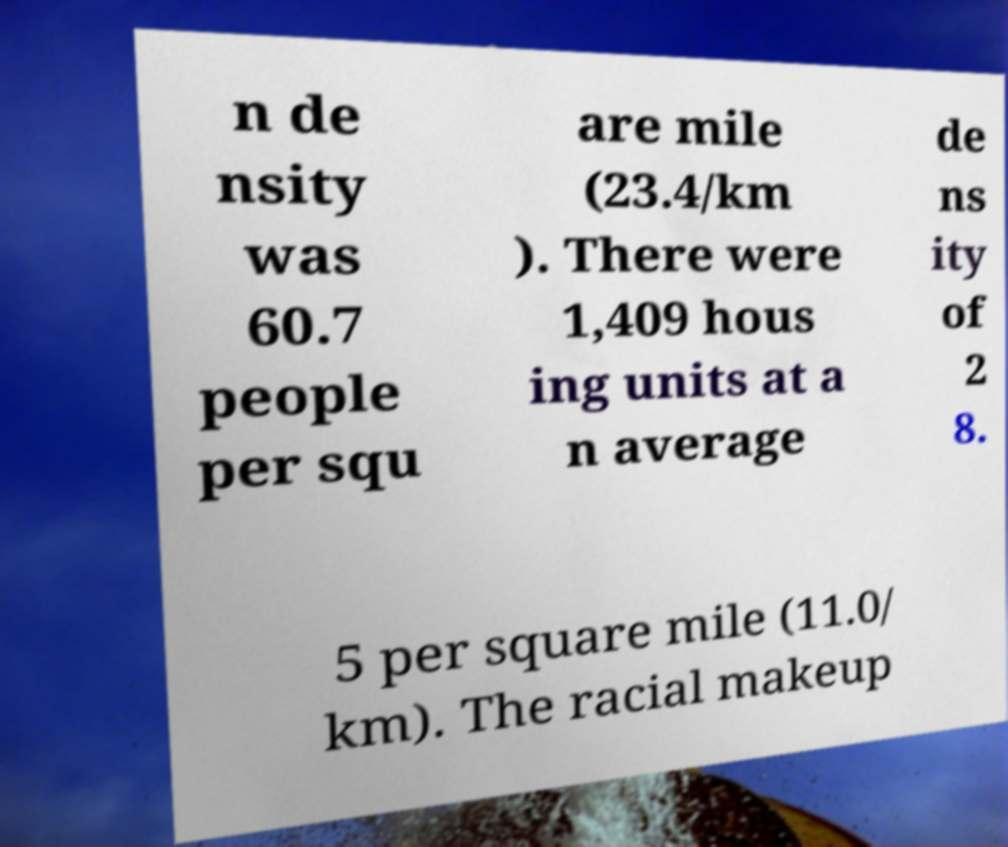What messages or text are displayed in this image? I need them in a readable, typed format. n de nsity was 60.7 people per squ are mile (23.4/km ). There were 1,409 hous ing units at a n average de ns ity of 2 8. 5 per square mile (11.0/ km). The racial makeup 